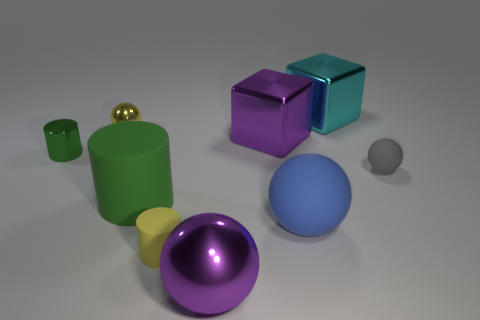Subtract all small gray rubber balls. How many balls are left? 3 Subtract all gray spheres. How many green cylinders are left? 2 Subtract all yellow cylinders. How many cylinders are left? 2 Subtract 0 blue cylinders. How many objects are left? 9 Subtract all cylinders. How many objects are left? 6 Subtract all red cylinders. Subtract all red blocks. How many cylinders are left? 3 Subtract all tiny gray things. Subtract all large metallic cubes. How many objects are left? 6 Add 5 balls. How many balls are left? 9 Add 1 tiny purple objects. How many tiny purple objects exist? 1 